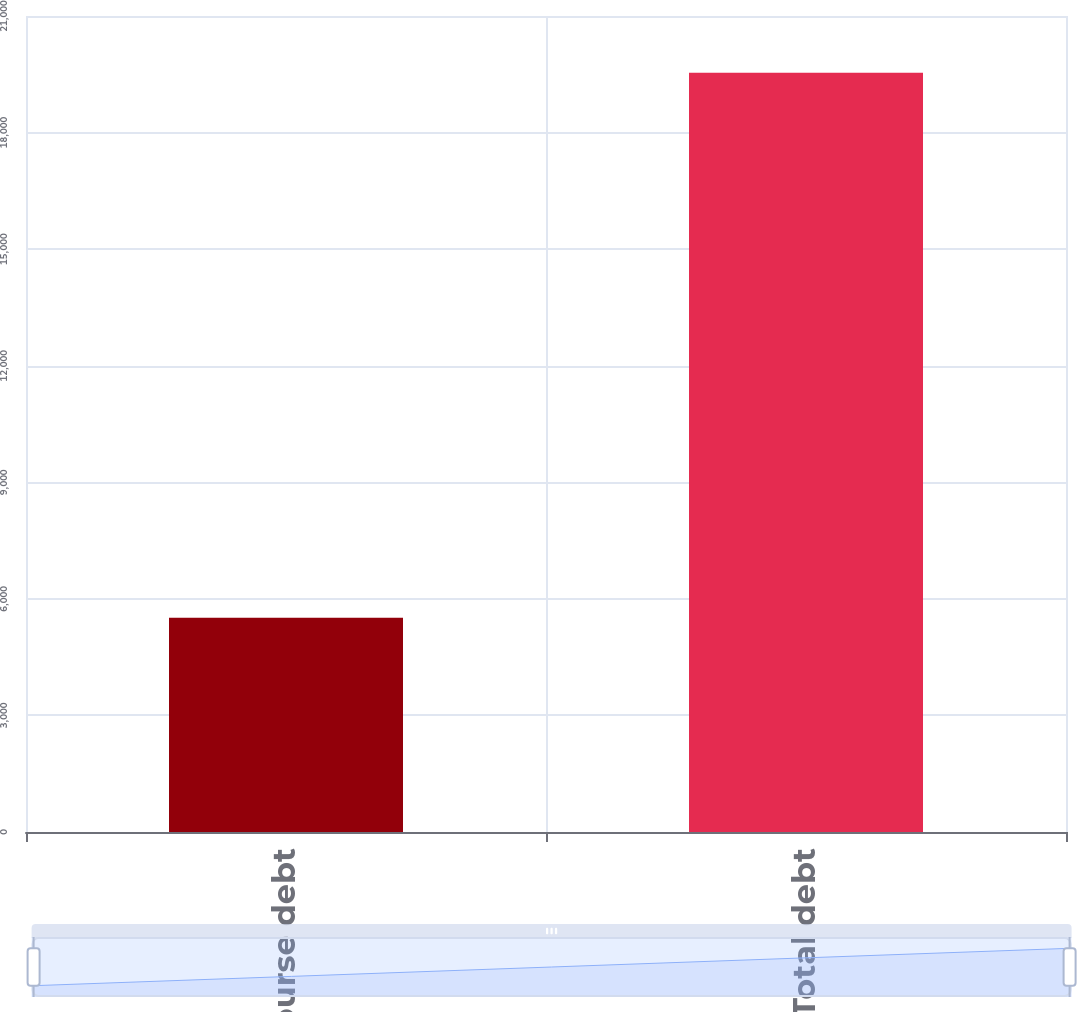Convert chart. <chart><loc_0><loc_0><loc_500><loc_500><bar_chart><fcel>Recourse debt<fcel>Total debt<nl><fcel>5515<fcel>19537<nl></chart> 